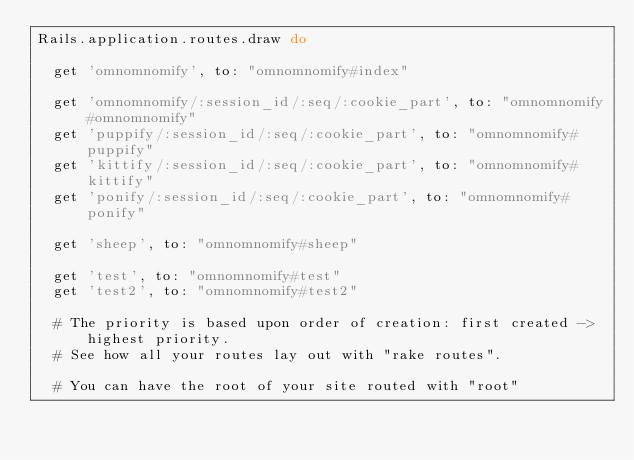<code> <loc_0><loc_0><loc_500><loc_500><_Ruby_>Rails.application.routes.draw do

  get 'omnomnomify', to: "omnomnomify#index"

  get 'omnomnomify/:session_id/:seq/:cookie_part', to: "omnomnomify#omnomnomify"
  get 'puppify/:session_id/:seq/:cookie_part', to: "omnomnomify#puppify"
  get 'kittify/:session_id/:seq/:cookie_part', to: "omnomnomify#kittify"
  get 'ponify/:session_id/:seq/:cookie_part', to: "omnomnomify#ponify"

  get 'sheep', to: "omnomnomify#sheep"

  get 'test', to: "omnomnomify#test"
  get 'test2', to: "omnomnomify#test2"

  # The priority is based upon order of creation: first created -> highest priority.
  # See how all your routes lay out with "rake routes".

  # You can have the root of your site routed with "root"</code> 